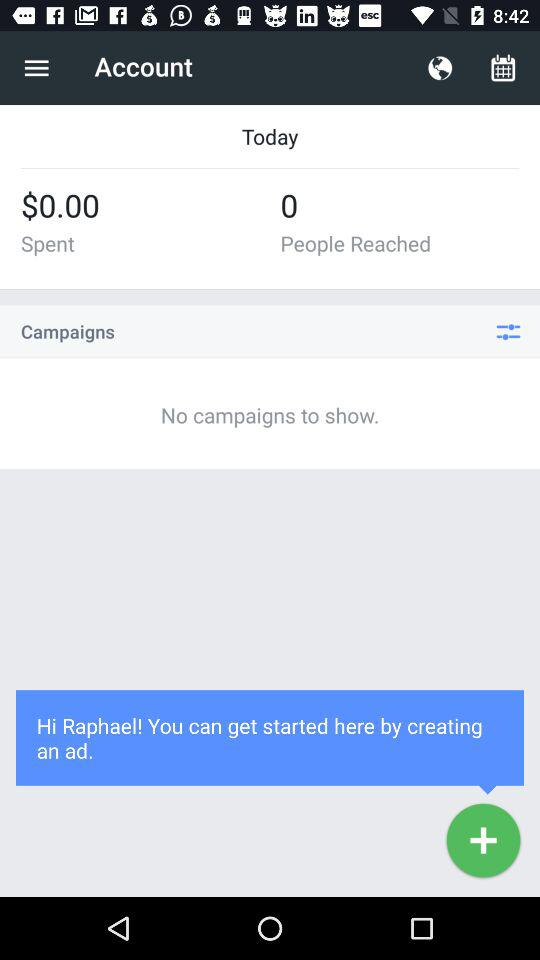How much money does an ad campaign cost?
When the provided information is insufficient, respond with <no answer>. <no answer> 